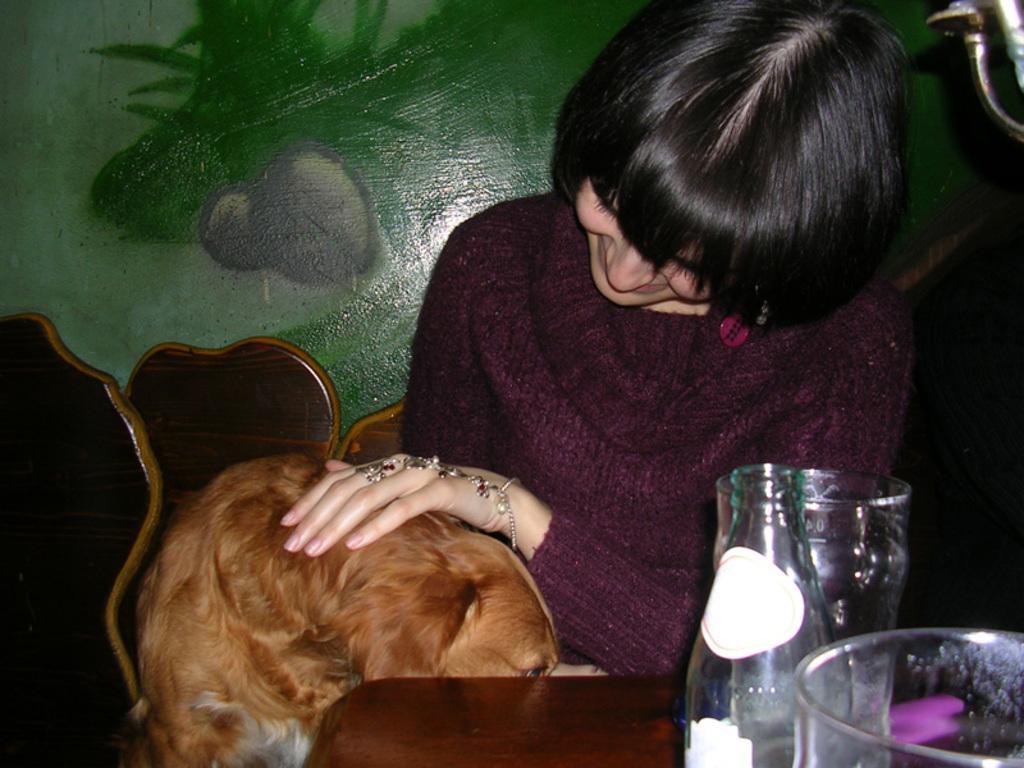Please provide a concise description of this image. In this image I see a woman who is sitting on the chair and she kept her hand on a dog and I can also there is a bottle and 2 glasses on the table. In the background I can see the wall. 